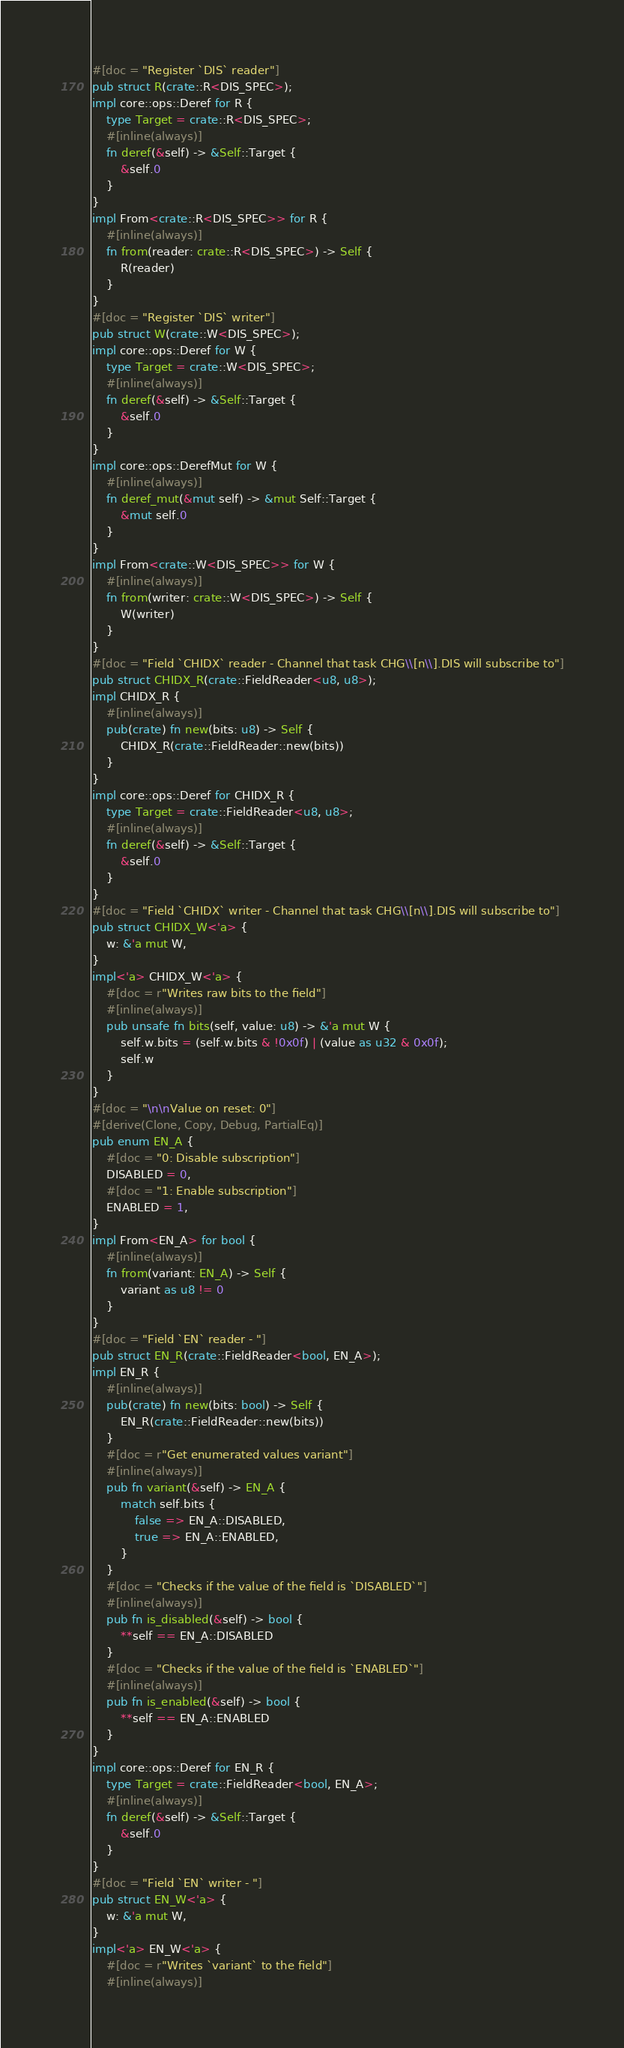Convert code to text. <code><loc_0><loc_0><loc_500><loc_500><_Rust_>#[doc = "Register `DIS` reader"]
pub struct R(crate::R<DIS_SPEC>);
impl core::ops::Deref for R {
    type Target = crate::R<DIS_SPEC>;
    #[inline(always)]
    fn deref(&self) -> &Self::Target {
        &self.0
    }
}
impl From<crate::R<DIS_SPEC>> for R {
    #[inline(always)]
    fn from(reader: crate::R<DIS_SPEC>) -> Self {
        R(reader)
    }
}
#[doc = "Register `DIS` writer"]
pub struct W(crate::W<DIS_SPEC>);
impl core::ops::Deref for W {
    type Target = crate::W<DIS_SPEC>;
    #[inline(always)]
    fn deref(&self) -> &Self::Target {
        &self.0
    }
}
impl core::ops::DerefMut for W {
    #[inline(always)]
    fn deref_mut(&mut self) -> &mut Self::Target {
        &mut self.0
    }
}
impl From<crate::W<DIS_SPEC>> for W {
    #[inline(always)]
    fn from(writer: crate::W<DIS_SPEC>) -> Self {
        W(writer)
    }
}
#[doc = "Field `CHIDX` reader - Channel that task CHG\\[n\\].DIS will subscribe to"]
pub struct CHIDX_R(crate::FieldReader<u8, u8>);
impl CHIDX_R {
    #[inline(always)]
    pub(crate) fn new(bits: u8) -> Self {
        CHIDX_R(crate::FieldReader::new(bits))
    }
}
impl core::ops::Deref for CHIDX_R {
    type Target = crate::FieldReader<u8, u8>;
    #[inline(always)]
    fn deref(&self) -> &Self::Target {
        &self.0
    }
}
#[doc = "Field `CHIDX` writer - Channel that task CHG\\[n\\].DIS will subscribe to"]
pub struct CHIDX_W<'a> {
    w: &'a mut W,
}
impl<'a> CHIDX_W<'a> {
    #[doc = r"Writes raw bits to the field"]
    #[inline(always)]
    pub unsafe fn bits(self, value: u8) -> &'a mut W {
        self.w.bits = (self.w.bits & !0x0f) | (value as u32 & 0x0f);
        self.w
    }
}
#[doc = "\n\nValue on reset: 0"]
#[derive(Clone, Copy, Debug, PartialEq)]
pub enum EN_A {
    #[doc = "0: Disable subscription"]
    DISABLED = 0,
    #[doc = "1: Enable subscription"]
    ENABLED = 1,
}
impl From<EN_A> for bool {
    #[inline(always)]
    fn from(variant: EN_A) -> Self {
        variant as u8 != 0
    }
}
#[doc = "Field `EN` reader - "]
pub struct EN_R(crate::FieldReader<bool, EN_A>);
impl EN_R {
    #[inline(always)]
    pub(crate) fn new(bits: bool) -> Self {
        EN_R(crate::FieldReader::new(bits))
    }
    #[doc = r"Get enumerated values variant"]
    #[inline(always)]
    pub fn variant(&self) -> EN_A {
        match self.bits {
            false => EN_A::DISABLED,
            true => EN_A::ENABLED,
        }
    }
    #[doc = "Checks if the value of the field is `DISABLED`"]
    #[inline(always)]
    pub fn is_disabled(&self) -> bool {
        **self == EN_A::DISABLED
    }
    #[doc = "Checks if the value of the field is `ENABLED`"]
    #[inline(always)]
    pub fn is_enabled(&self) -> bool {
        **self == EN_A::ENABLED
    }
}
impl core::ops::Deref for EN_R {
    type Target = crate::FieldReader<bool, EN_A>;
    #[inline(always)]
    fn deref(&self) -> &Self::Target {
        &self.0
    }
}
#[doc = "Field `EN` writer - "]
pub struct EN_W<'a> {
    w: &'a mut W,
}
impl<'a> EN_W<'a> {
    #[doc = r"Writes `variant` to the field"]
    #[inline(always)]</code> 